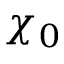<formula> <loc_0><loc_0><loc_500><loc_500>\chi _ { 0 }</formula> 